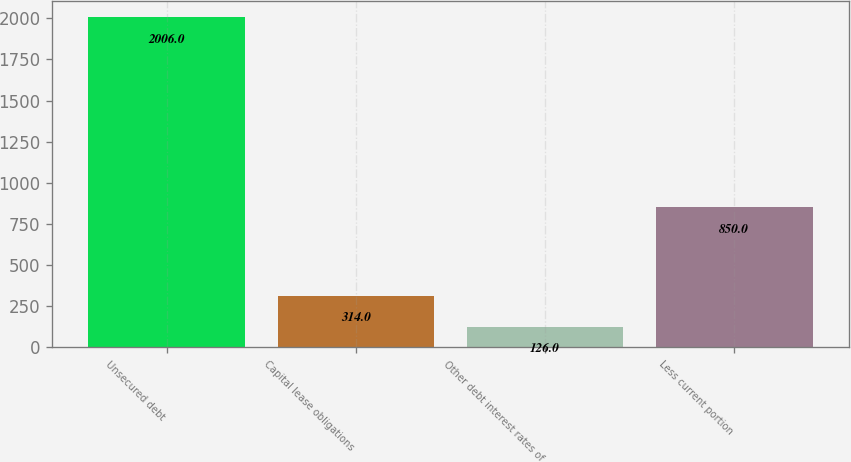Convert chart to OTSL. <chart><loc_0><loc_0><loc_500><loc_500><bar_chart><fcel>Unsecured debt<fcel>Capital lease obligations<fcel>Other debt interest rates of<fcel>Less current portion<nl><fcel>2006<fcel>314<fcel>126<fcel>850<nl></chart> 